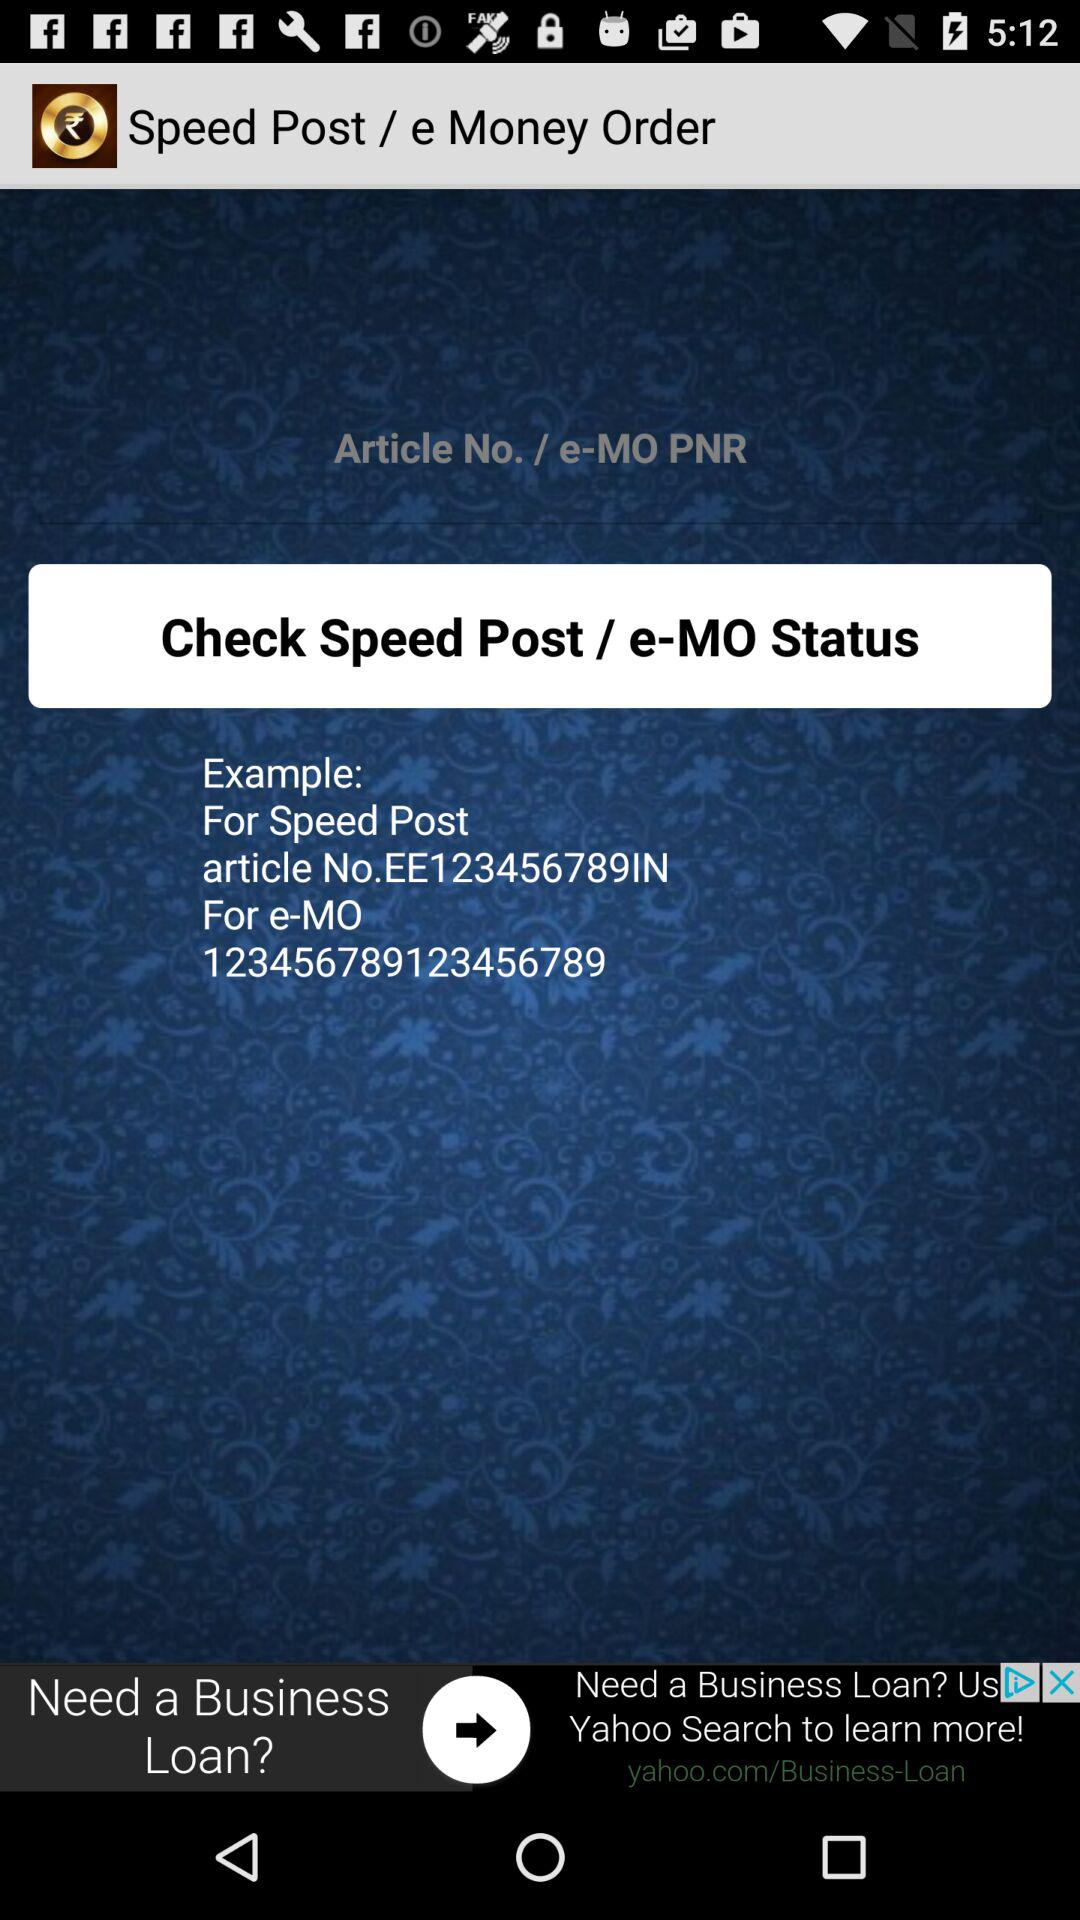What is the article number for the speed post? The article number is EE123456789IN. 